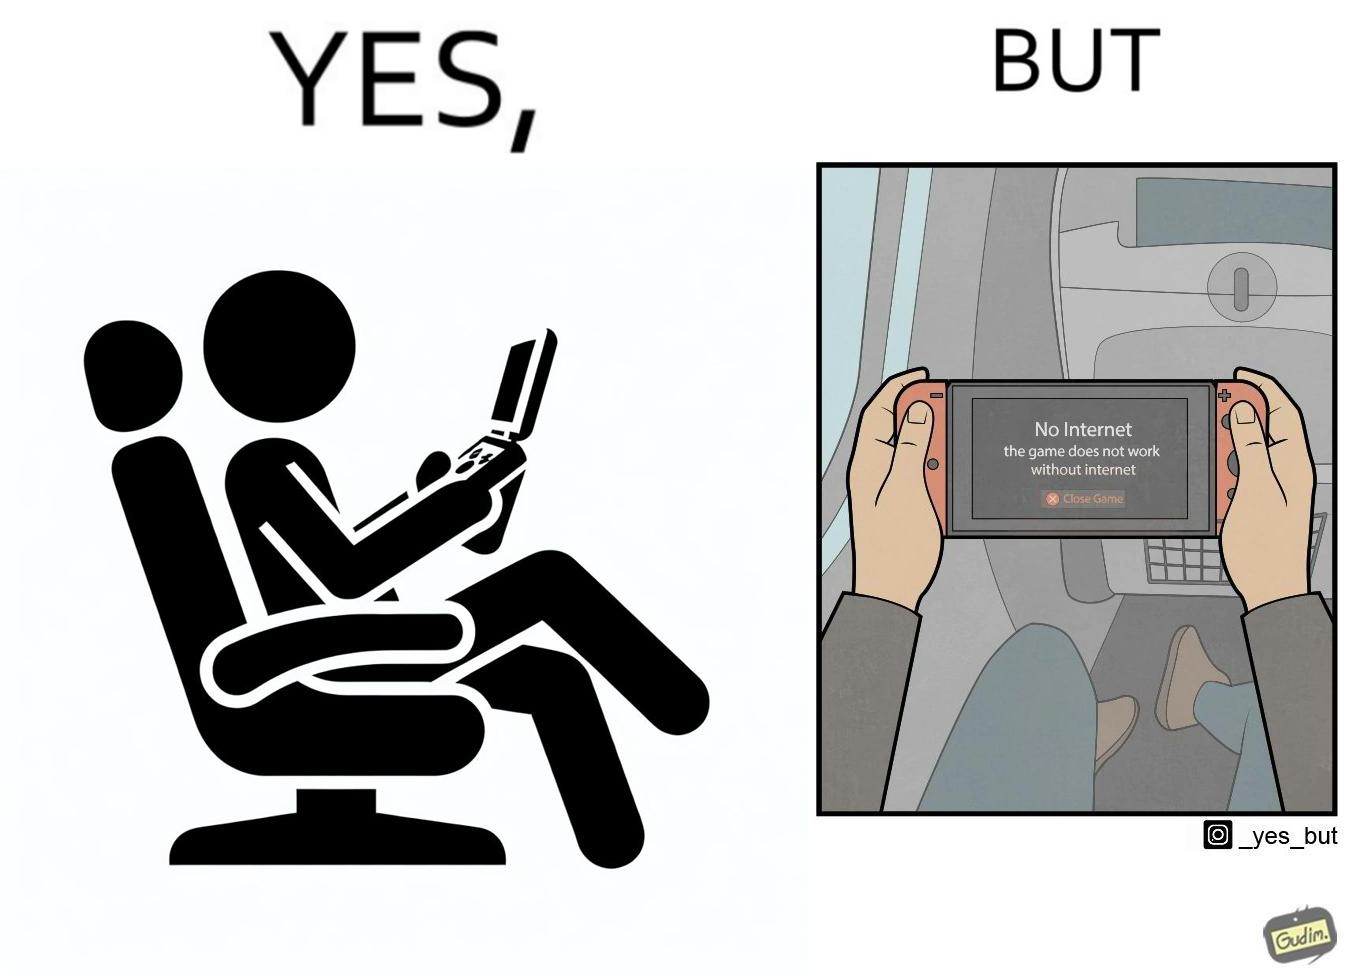What is shown in the left half versus the right half of this image? In the left part of the image: a person sitting in a flight seat, with a gaming console in the person's hands. In the right part of the image: a person sitting in a flight seat, with a gaming console in the person's hands, with a message which shows "No Internet, the game does not work without internet". 